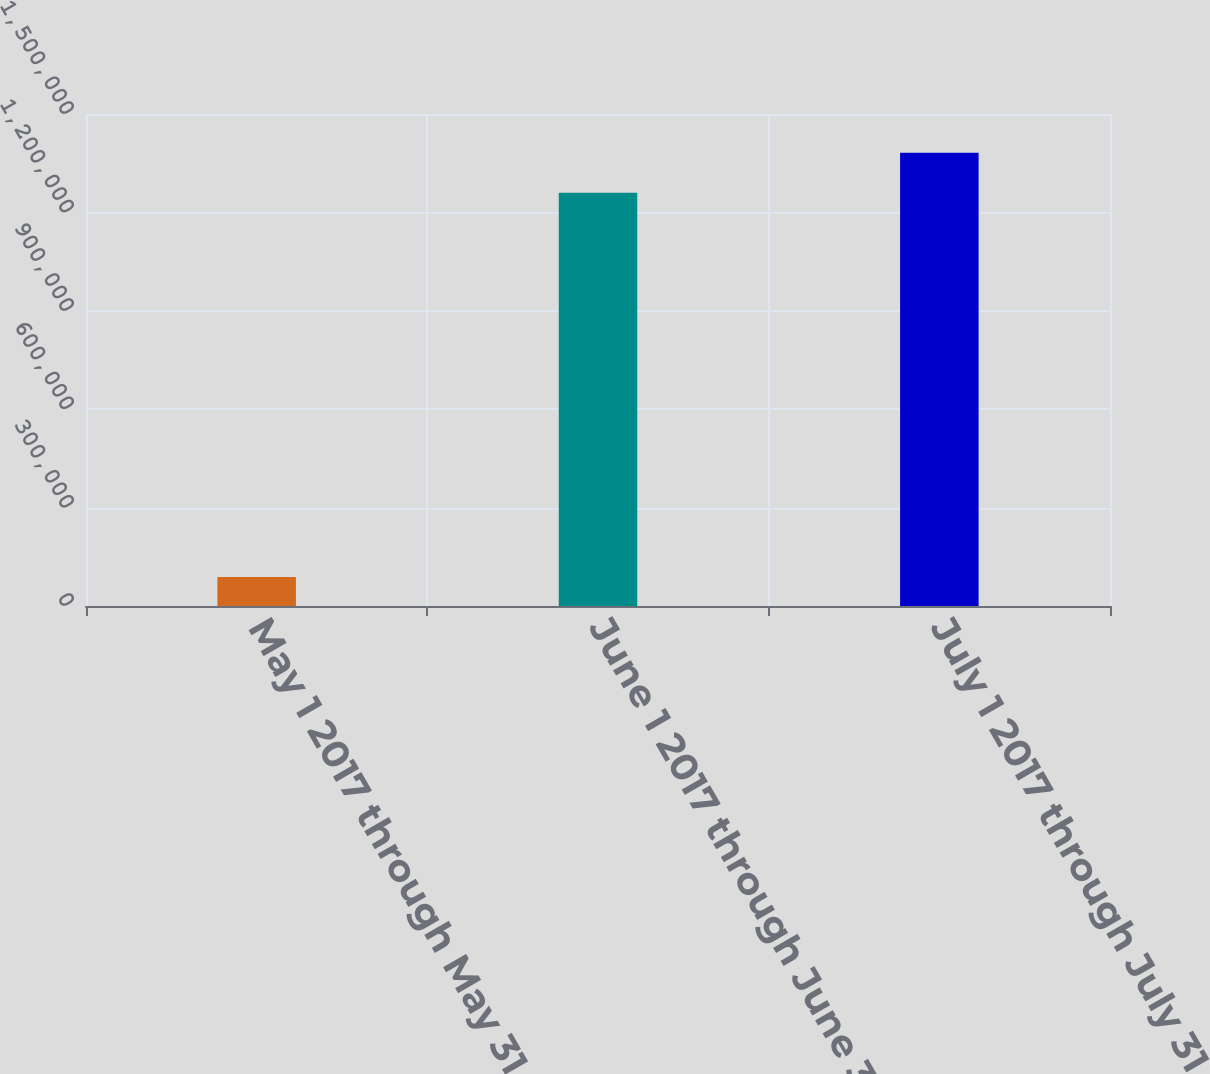Convert chart. <chart><loc_0><loc_0><loc_500><loc_500><bar_chart><fcel>May 1 2017 through May 31 2017<fcel>June 1 2017 through June 30<fcel>July 1 2017 through July 31<nl><fcel>88429<fcel>1.26e+06<fcel>1.38221e+06<nl></chart> 